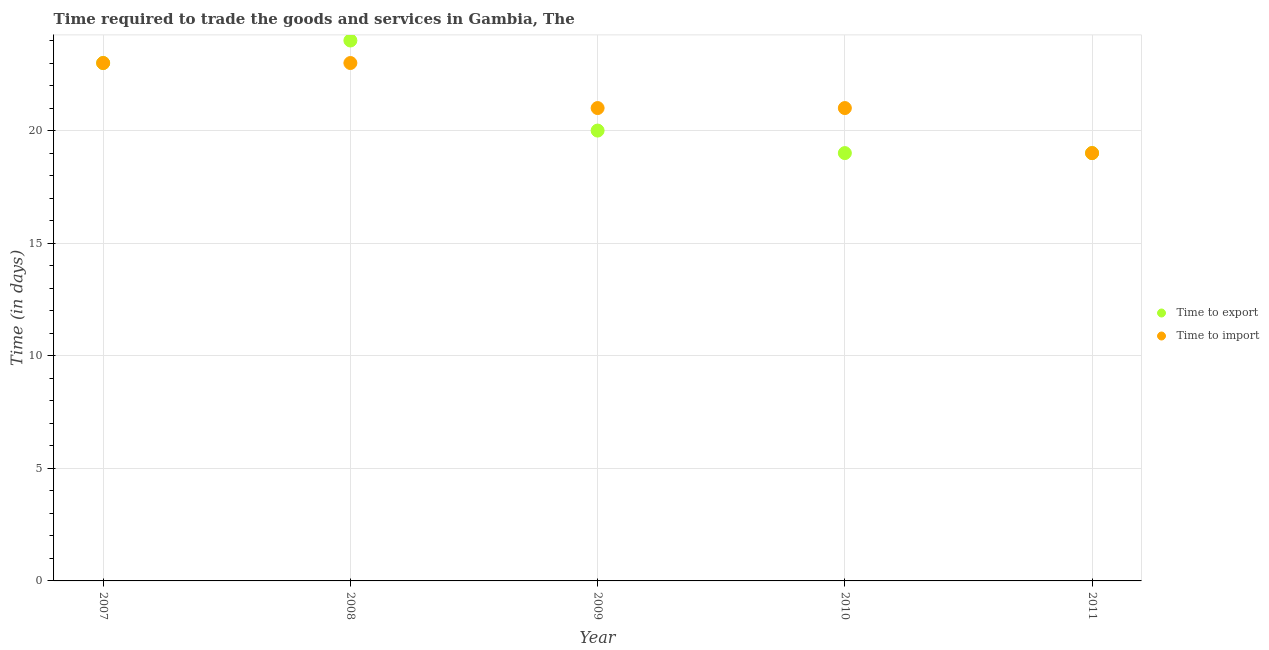How many different coloured dotlines are there?
Ensure brevity in your answer.  2. What is the time to import in 2007?
Ensure brevity in your answer.  23. Across all years, what is the maximum time to import?
Your answer should be very brief. 23. Across all years, what is the minimum time to export?
Ensure brevity in your answer.  19. In which year was the time to export minimum?
Make the answer very short. 2010. What is the total time to import in the graph?
Your answer should be compact. 107. What is the difference between the time to export in 2010 and that in 2011?
Your answer should be compact. 0. What is the difference between the time to export in 2011 and the time to import in 2008?
Provide a succinct answer. -4. What is the average time to export per year?
Your response must be concise. 21. In the year 2007, what is the difference between the time to export and time to import?
Offer a very short reply. 0. What is the ratio of the time to import in 2007 to that in 2009?
Your answer should be compact. 1.1. What is the difference between the highest and the lowest time to export?
Your answer should be compact. 5. In how many years, is the time to import greater than the average time to import taken over all years?
Ensure brevity in your answer.  2. Does the time to import monotonically increase over the years?
Give a very brief answer. No. Is the time to import strictly less than the time to export over the years?
Your answer should be very brief. No. Are the values on the major ticks of Y-axis written in scientific E-notation?
Ensure brevity in your answer.  No. Does the graph contain any zero values?
Offer a terse response. No. Does the graph contain grids?
Your answer should be very brief. Yes. Where does the legend appear in the graph?
Your response must be concise. Center right. How many legend labels are there?
Provide a short and direct response. 2. What is the title of the graph?
Provide a succinct answer. Time required to trade the goods and services in Gambia, The. Does "Non-residents" appear as one of the legend labels in the graph?
Provide a succinct answer. No. What is the label or title of the X-axis?
Make the answer very short. Year. What is the label or title of the Y-axis?
Your answer should be compact. Time (in days). What is the Time (in days) of Time to export in 2007?
Your answer should be compact. 23. What is the Time (in days) of Time to export in 2008?
Make the answer very short. 24. What is the Time (in days) of Time to import in 2008?
Ensure brevity in your answer.  23. What is the Time (in days) of Time to export in 2011?
Provide a succinct answer. 19. What is the Time (in days) in Time to import in 2011?
Provide a short and direct response. 19. Across all years, what is the maximum Time (in days) in Time to import?
Make the answer very short. 23. What is the total Time (in days) in Time to export in the graph?
Ensure brevity in your answer.  105. What is the total Time (in days) in Time to import in the graph?
Provide a succinct answer. 107. What is the difference between the Time (in days) in Time to import in 2007 and that in 2008?
Provide a succinct answer. 0. What is the difference between the Time (in days) in Time to export in 2007 and that in 2009?
Make the answer very short. 3. What is the difference between the Time (in days) in Time to export in 2007 and that in 2010?
Give a very brief answer. 4. What is the difference between the Time (in days) of Time to export in 2007 and that in 2011?
Give a very brief answer. 4. What is the difference between the Time (in days) in Time to import in 2007 and that in 2011?
Provide a short and direct response. 4. What is the difference between the Time (in days) of Time to export in 2008 and that in 2010?
Your response must be concise. 5. What is the difference between the Time (in days) of Time to import in 2008 and that in 2011?
Ensure brevity in your answer.  4. What is the difference between the Time (in days) of Time to export in 2007 and the Time (in days) of Time to import in 2008?
Give a very brief answer. 0. What is the difference between the Time (in days) of Time to export in 2007 and the Time (in days) of Time to import in 2009?
Provide a short and direct response. 2. What is the difference between the Time (in days) of Time to export in 2007 and the Time (in days) of Time to import in 2011?
Provide a succinct answer. 4. What is the difference between the Time (in days) of Time to export in 2008 and the Time (in days) of Time to import in 2009?
Keep it short and to the point. 3. What is the difference between the Time (in days) of Time to export in 2008 and the Time (in days) of Time to import in 2010?
Offer a terse response. 3. What is the difference between the Time (in days) of Time to export in 2008 and the Time (in days) of Time to import in 2011?
Give a very brief answer. 5. What is the difference between the Time (in days) of Time to export in 2009 and the Time (in days) of Time to import in 2010?
Make the answer very short. -1. What is the difference between the Time (in days) of Time to export in 2009 and the Time (in days) of Time to import in 2011?
Your response must be concise. 1. What is the average Time (in days) in Time to import per year?
Ensure brevity in your answer.  21.4. In the year 2008, what is the difference between the Time (in days) in Time to export and Time (in days) in Time to import?
Offer a very short reply. 1. In the year 2009, what is the difference between the Time (in days) of Time to export and Time (in days) of Time to import?
Provide a succinct answer. -1. In the year 2010, what is the difference between the Time (in days) in Time to export and Time (in days) in Time to import?
Keep it short and to the point. -2. What is the ratio of the Time (in days) in Time to export in 2007 to that in 2008?
Provide a short and direct response. 0.96. What is the ratio of the Time (in days) in Time to export in 2007 to that in 2009?
Make the answer very short. 1.15. What is the ratio of the Time (in days) in Time to import in 2007 to that in 2009?
Your response must be concise. 1.1. What is the ratio of the Time (in days) in Time to export in 2007 to that in 2010?
Give a very brief answer. 1.21. What is the ratio of the Time (in days) of Time to import in 2007 to that in 2010?
Give a very brief answer. 1.1. What is the ratio of the Time (in days) in Time to export in 2007 to that in 2011?
Keep it short and to the point. 1.21. What is the ratio of the Time (in days) of Time to import in 2007 to that in 2011?
Your response must be concise. 1.21. What is the ratio of the Time (in days) of Time to import in 2008 to that in 2009?
Offer a terse response. 1.1. What is the ratio of the Time (in days) in Time to export in 2008 to that in 2010?
Provide a short and direct response. 1.26. What is the ratio of the Time (in days) of Time to import in 2008 to that in 2010?
Offer a terse response. 1.1. What is the ratio of the Time (in days) of Time to export in 2008 to that in 2011?
Give a very brief answer. 1.26. What is the ratio of the Time (in days) in Time to import in 2008 to that in 2011?
Your response must be concise. 1.21. What is the ratio of the Time (in days) of Time to export in 2009 to that in 2010?
Provide a short and direct response. 1.05. What is the ratio of the Time (in days) of Time to export in 2009 to that in 2011?
Keep it short and to the point. 1.05. What is the ratio of the Time (in days) of Time to import in 2009 to that in 2011?
Your answer should be compact. 1.11. What is the ratio of the Time (in days) in Time to export in 2010 to that in 2011?
Ensure brevity in your answer.  1. What is the ratio of the Time (in days) in Time to import in 2010 to that in 2011?
Keep it short and to the point. 1.11. What is the difference between the highest and the lowest Time (in days) of Time to import?
Make the answer very short. 4. 